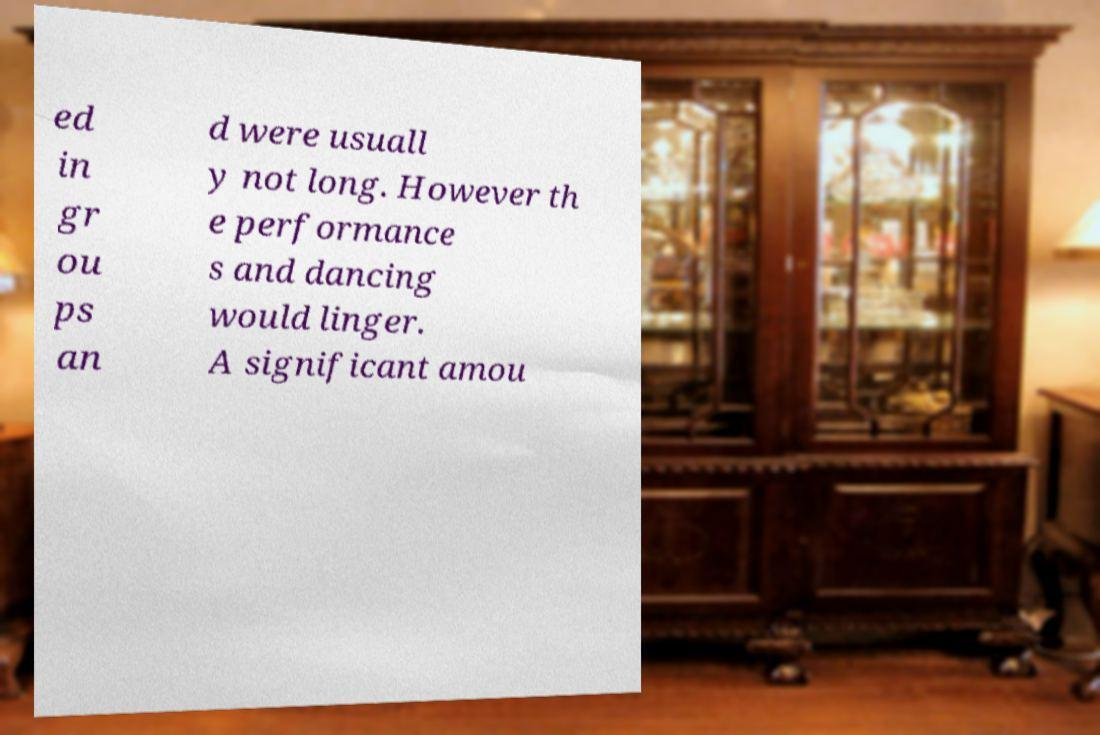Could you extract and type out the text from this image? ed in gr ou ps an d were usuall y not long. However th e performance s and dancing would linger. A significant amou 